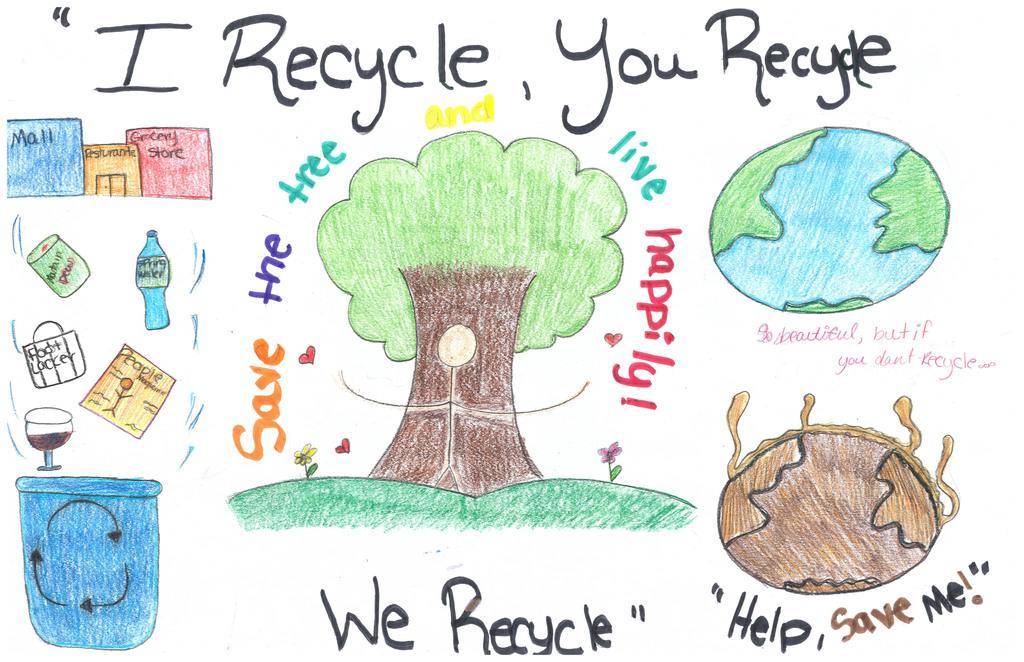How would you summarize this image in a sentence or two? In the picture I can see a drawing of a tree, a glass, a bottle,a bucket, flowers and some other things. I can also see something written on the image. 